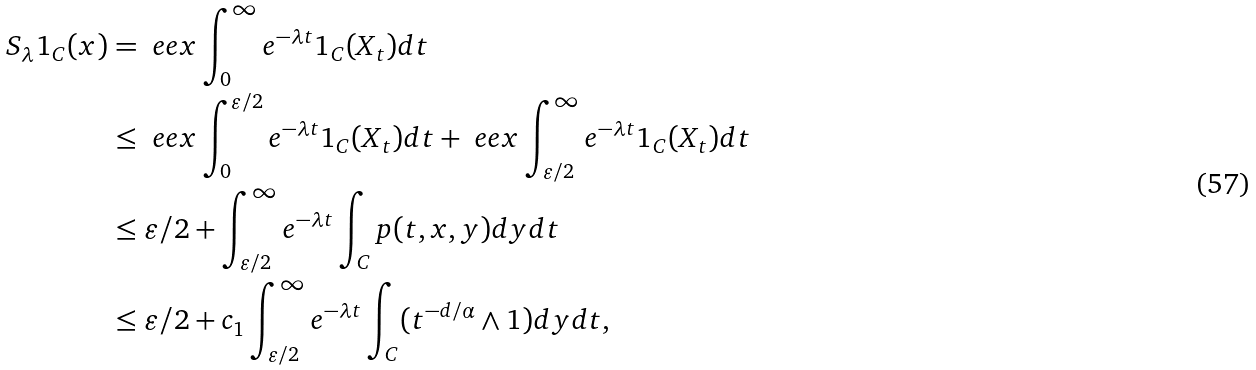<formula> <loc_0><loc_0><loc_500><loc_500>S _ { \lambda } 1 _ { C } ( x ) & = \ e e x \int _ { 0 } ^ { \infty } e ^ { - \lambda t } 1 _ { C } ( X _ { t } ) d t \\ & \leq \ e e x \int _ { 0 } ^ { \varepsilon / 2 } e ^ { - \lambda t } 1 _ { C } ( X _ { t } ) d t + \ e e x \int _ { \varepsilon / 2 } ^ { \infty } e ^ { - \lambda t } 1 _ { C } ( X _ { t } ) d t \\ & \leq { \varepsilon } / { 2 } + \int _ { \varepsilon / 2 } ^ { \infty } e ^ { - \lambda t } \int _ { C } p ( t , x , y ) d y d t \\ & \leq { \varepsilon } / { 2 } + c _ { 1 } \int _ { \varepsilon / 2 } ^ { \infty } e ^ { - \lambda t } \int _ { C } ( t ^ { - d / \alpha } \wedge 1 ) d y d t ,</formula> 